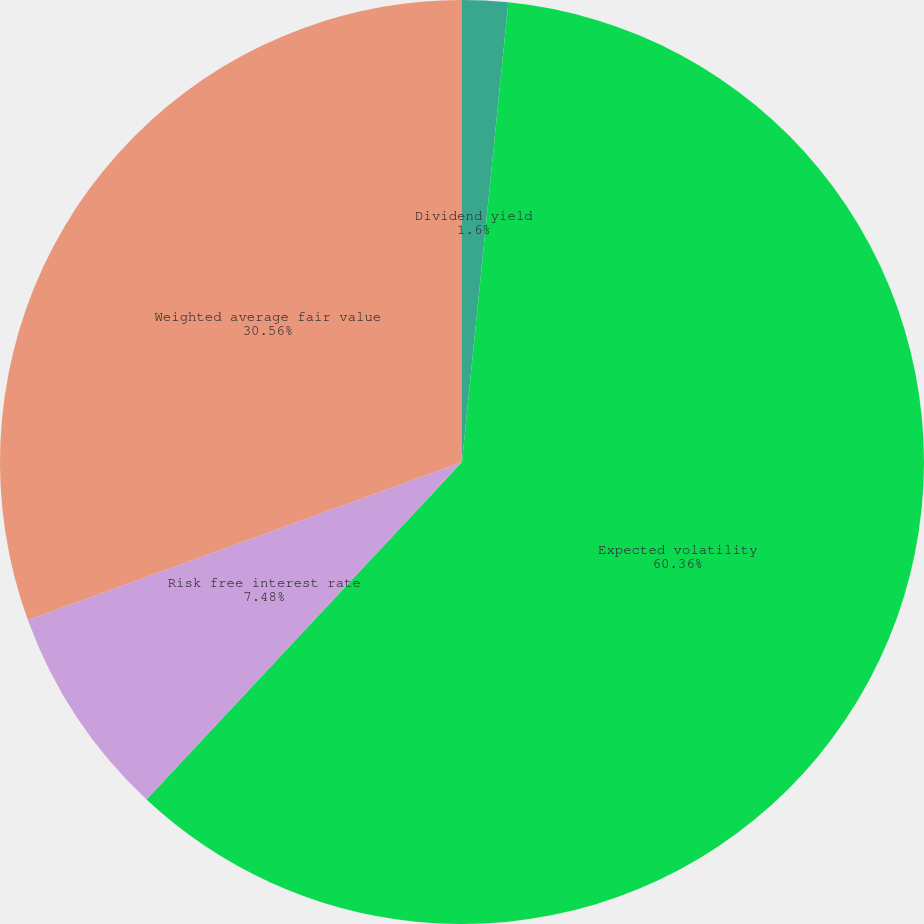<chart> <loc_0><loc_0><loc_500><loc_500><pie_chart><fcel>Dividend yield<fcel>Expected volatility<fcel>Risk free interest rate<fcel>Weighted average fair value<nl><fcel>1.6%<fcel>60.37%<fcel>7.48%<fcel>30.56%<nl></chart> 